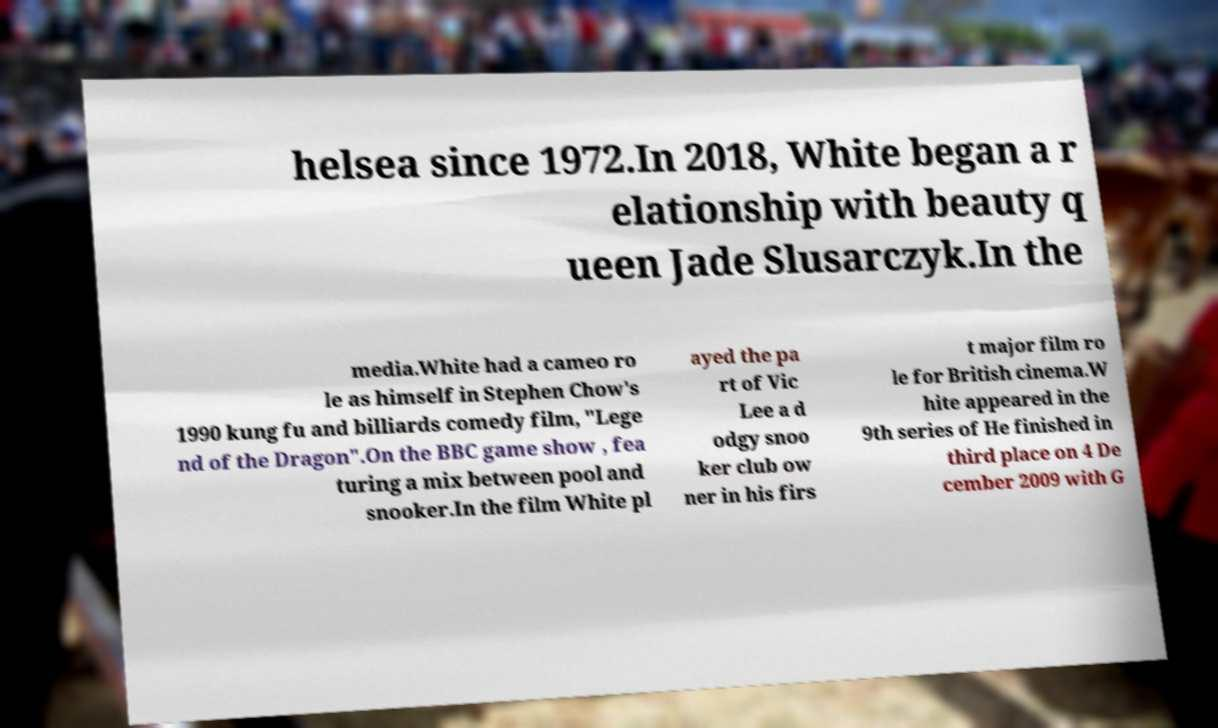What messages or text are displayed in this image? I need them in a readable, typed format. helsea since 1972.In 2018, White began a r elationship with beauty q ueen Jade Slusarczyk.In the media.White had a cameo ro le as himself in Stephen Chow's 1990 kung fu and billiards comedy film, "Lege nd of the Dragon".On the BBC game show , fea turing a mix between pool and snooker.In the film White pl ayed the pa rt of Vic Lee a d odgy snoo ker club ow ner in his firs t major film ro le for British cinema.W hite appeared in the 9th series of He finished in third place on 4 De cember 2009 with G 